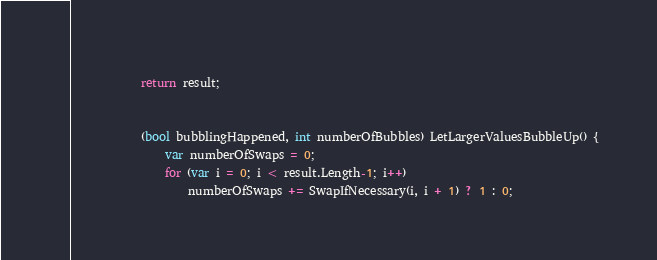Convert code to text. <code><loc_0><loc_0><loc_500><loc_500><_C#_>            
            return result;


            (bool bubblingHappened, int numberOfBubbles) LetLargerValuesBubbleUp() {
                var numberOfSwaps = 0;
                for (var i = 0; i < result.Length-1; i++)
                    numberOfSwaps += SwapIfNecessary(i, i + 1) ? 1 : 0;</code> 